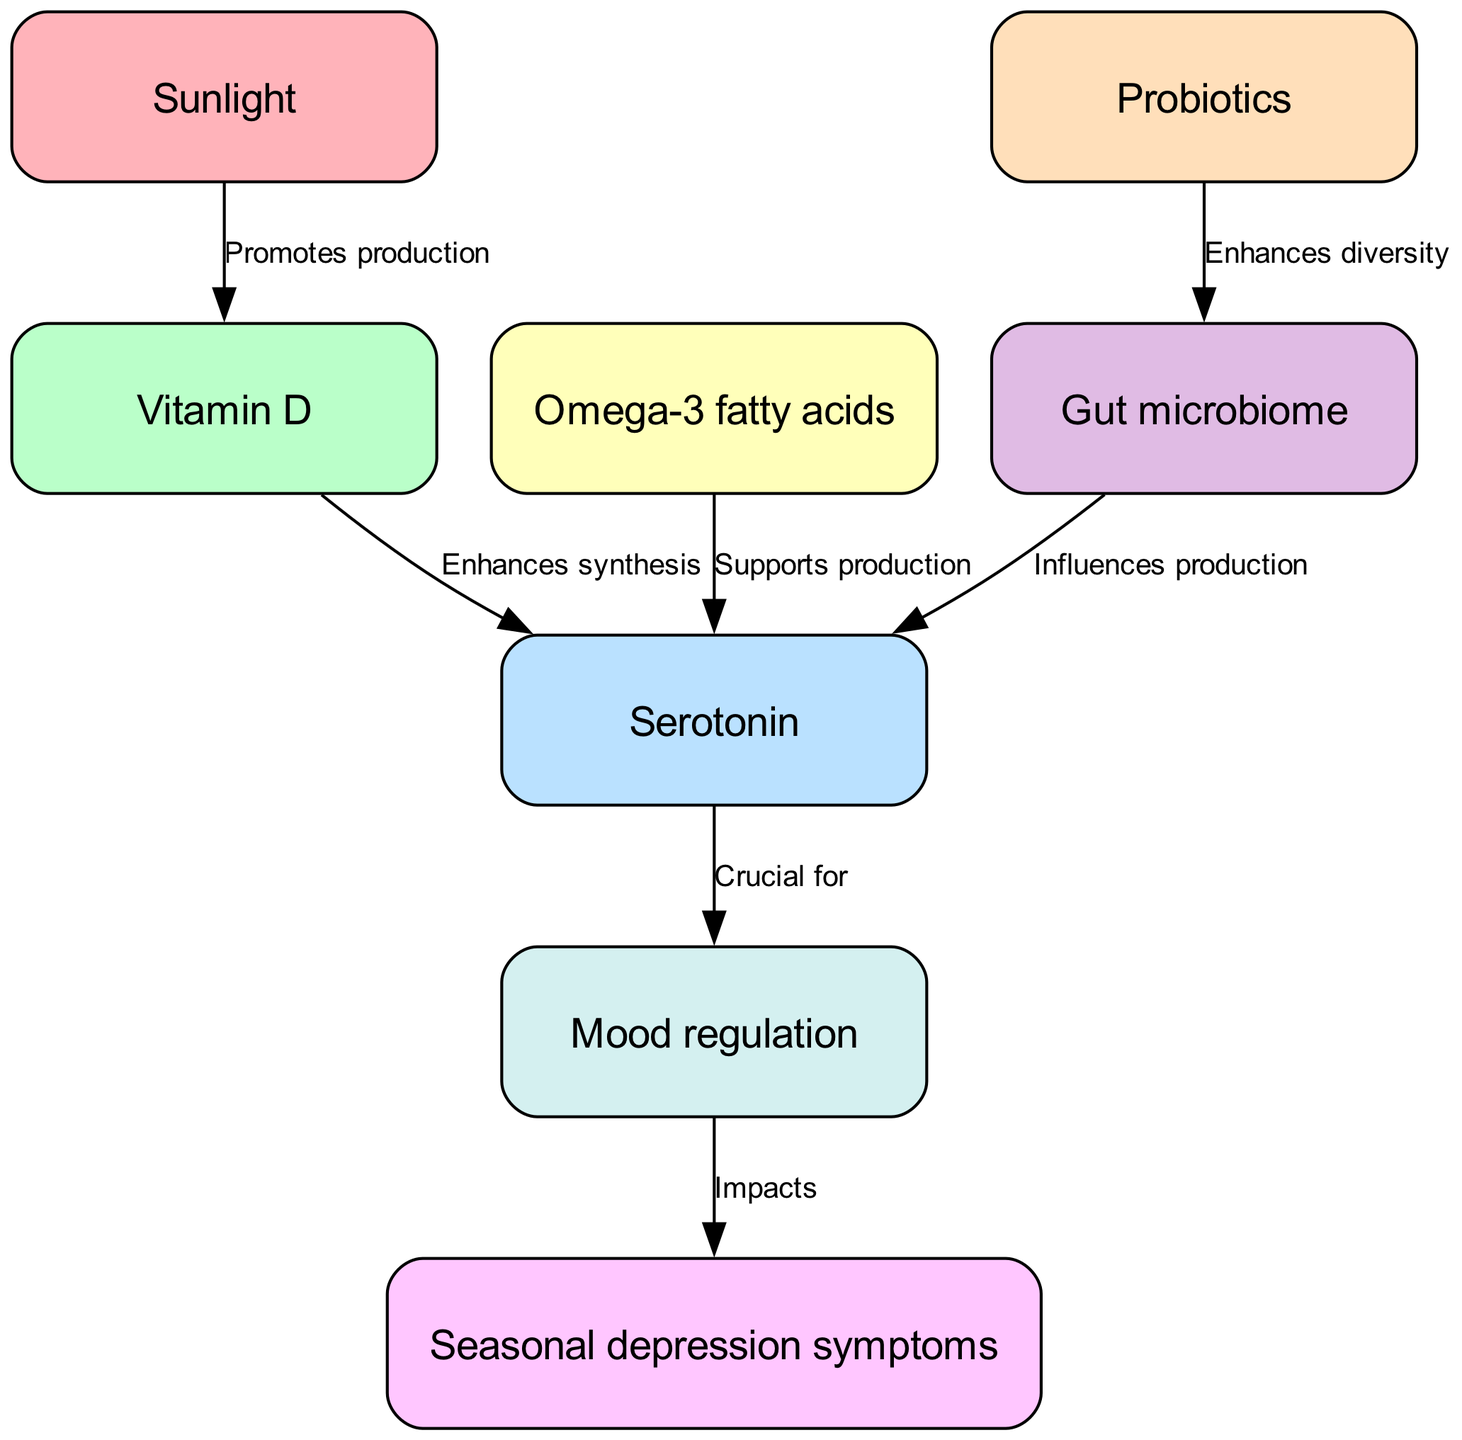What promotes the production of Vitamin D? In the diagram, there is a directed edge from "Sunlight" to "Vitamin D" labeled "Promotes production." This indicates that sunlight influences the production of Vitamin D.
Answer: Sunlight What is crucial for mood regulation? The diagram shows an edge from "Serotonin" to "Mood regulation" labeled "Crucial for," indicating that serotonin plays a key role in regulating mood.
Answer: Serotonin How many edges are there in total? By counting the directed connections (edges) in the diagram, we find that there are 6 edges connecting the various nodes.
Answer: 6 What influences the production of Serotonin? There are two edges leading to "Serotonin": one from "Vitamin D" labeled "Enhances synthesis" and another from "Gut microbiome" labeled "Influences production." Both these connections show that they contribute to serotonin production.
Answer: Vitamin D, Gut microbiome What impacts seasonal depression symptoms? The diagram has an edge from "Mood regulation" to "Seasonal depression symptoms" labeled "Impacts." This indicates that the regulation of mood directly affects the severity or occurrence of seasonal depression symptoms.
Answer: Mood regulation Which node enhances diversity in the gut microbiome? According to the diagram, there is a directed edge from "Probiotics" to "Gut microbiome" labeled "Enhances diversity," indicating that probiotics are responsible for increasing the diversity within the gut microbiome.
Answer: Probiotics Which nutrient supports the production of Serotonin? The diagram includes an edge from "Omega-3 fatty acids" to "Serotonin" labeled "Supports production," demonstrating that omega-3 fatty acids contribute positively to serotonin levels.
Answer: Omega-3 fatty acids How are Omega-3 fatty acids related to seasonal depression symptoms? We can trace the relationship as follows: Omega-3 fatty acids support the production of Serotonin, which is crucial for mood regulation. Mood regulation, in turn, impacts seasonal depression symptoms. This shows a chain that links omega-3 fatty acids to seasonal depression indirectly through serotonin and mood regulation.
Answer: Indirectly Which node is the starting point of the food chain in this context? In the diagram, the starting point or the source of many influences is "Sunlight," as it is the first node connected to other nodes in the food chain, promoting the production of Vitamin D.
Answer: Sunlight 